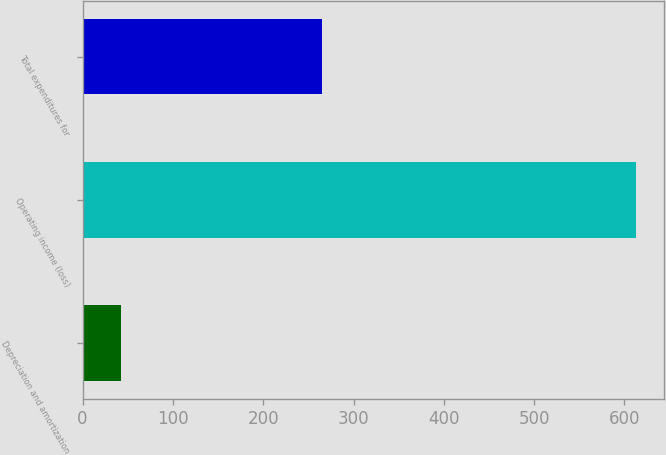Convert chart to OTSL. <chart><loc_0><loc_0><loc_500><loc_500><bar_chart><fcel>Depreciation and amortization<fcel>Operating income (loss)<fcel>Total expenditures for<nl><fcel>42<fcel>613<fcel>265<nl></chart> 